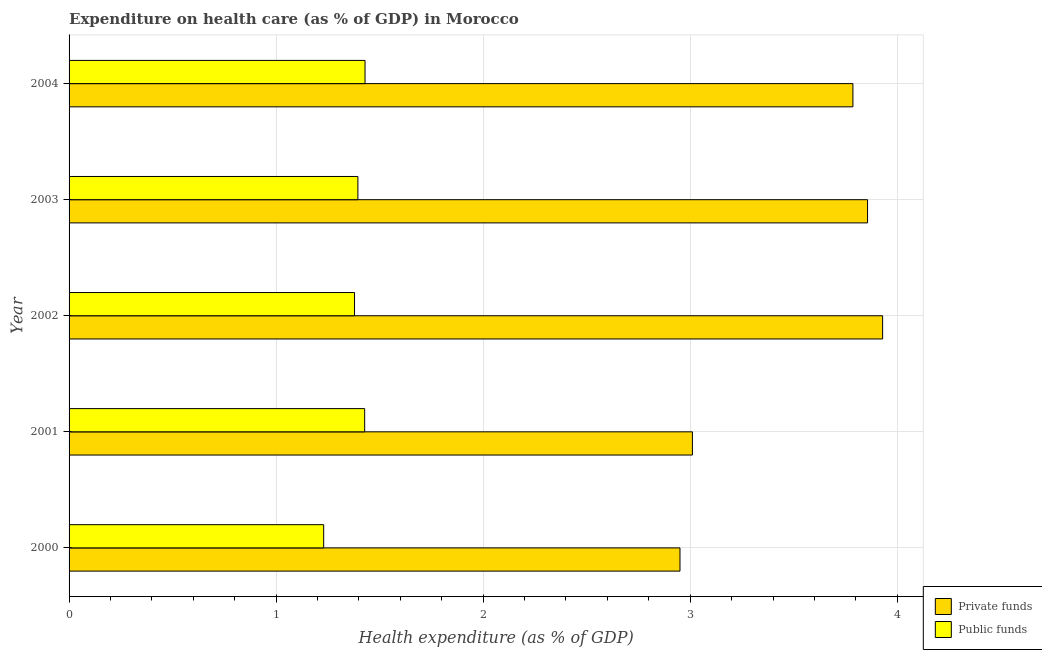Are the number of bars per tick equal to the number of legend labels?
Provide a succinct answer. Yes. Are the number of bars on each tick of the Y-axis equal?
Keep it short and to the point. Yes. How many bars are there on the 4th tick from the bottom?
Provide a short and direct response. 2. In how many cases, is the number of bars for a given year not equal to the number of legend labels?
Your response must be concise. 0. What is the amount of private funds spent in healthcare in 2004?
Offer a terse response. 3.79. Across all years, what is the maximum amount of public funds spent in healthcare?
Your response must be concise. 1.43. Across all years, what is the minimum amount of public funds spent in healthcare?
Offer a terse response. 1.23. What is the total amount of private funds spent in healthcare in the graph?
Provide a short and direct response. 17.53. What is the difference between the amount of private funds spent in healthcare in 2000 and that in 2003?
Your response must be concise. -0.91. What is the difference between the amount of public funds spent in healthcare in 2002 and the amount of private funds spent in healthcare in 2003?
Your response must be concise. -2.48. What is the average amount of public funds spent in healthcare per year?
Offer a very short reply. 1.37. In the year 2000, what is the difference between the amount of public funds spent in healthcare and amount of private funds spent in healthcare?
Your answer should be compact. -1.72. In how many years, is the amount of private funds spent in healthcare greater than 2.8 %?
Keep it short and to the point. 5. What is the ratio of the amount of private funds spent in healthcare in 2002 to that in 2004?
Provide a succinct answer. 1.04. What is the difference between the highest and the second highest amount of public funds spent in healthcare?
Your answer should be compact. 0. In how many years, is the amount of private funds spent in healthcare greater than the average amount of private funds spent in healthcare taken over all years?
Give a very brief answer. 3. What does the 2nd bar from the top in 2000 represents?
Ensure brevity in your answer.  Private funds. What does the 2nd bar from the bottom in 2004 represents?
Provide a succinct answer. Public funds. Are the values on the major ticks of X-axis written in scientific E-notation?
Your answer should be very brief. No. Does the graph contain any zero values?
Ensure brevity in your answer.  No. Does the graph contain grids?
Provide a short and direct response. Yes. Where does the legend appear in the graph?
Ensure brevity in your answer.  Bottom right. How many legend labels are there?
Ensure brevity in your answer.  2. What is the title of the graph?
Your response must be concise. Expenditure on health care (as % of GDP) in Morocco. Does "Non-pregnant women" appear as one of the legend labels in the graph?
Offer a terse response. No. What is the label or title of the X-axis?
Offer a very short reply. Health expenditure (as % of GDP). What is the label or title of the Y-axis?
Your answer should be compact. Year. What is the Health expenditure (as % of GDP) in Private funds in 2000?
Your answer should be very brief. 2.95. What is the Health expenditure (as % of GDP) in Public funds in 2000?
Provide a short and direct response. 1.23. What is the Health expenditure (as % of GDP) of Private funds in 2001?
Give a very brief answer. 3.01. What is the Health expenditure (as % of GDP) in Public funds in 2001?
Offer a terse response. 1.43. What is the Health expenditure (as % of GDP) of Private funds in 2002?
Your answer should be very brief. 3.93. What is the Health expenditure (as % of GDP) in Public funds in 2002?
Keep it short and to the point. 1.38. What is the Health expenditure (as % of GDP) in Private funds in 2003?
Your response must be concise. 3.86. What is the Health expenditure (as % of GDP) in Public funds in 2003?
Your response must be concise. 1.39. What is the Health expenditure (as % of GDP) of Private funds in 2004?
Your response must be concise. 3.79. What is the Health expenditure (as % of GDP) in Public funds in 2004?
Offer a terse response. 1.43. Across all years, what is the maximum Health expenditure (as % of GDP) of Private funds?
Your answer should be compact. 3.93. Across all years, what is the maximum Health expenditure (as % of GDP) in Public funds?
Keep it short and to the point. 1.43. Across all years, what is the minimum Health expenditure (as % of GDP) of Private funds?
Ensure brevity in your answer.  2.95. Across all years, what is the minimum Health expenditure (as % of GDP) in Public funds?
Give a very brief answer. 1.23. What is the total Health expenditure (as % of GDP) in Private funds in the graph?
Ensure brevity in your answer.  17.53. What is the total Health expenditure (as % of GDP) of Public funds in the graph?
Ensure brevity in your answer.  6.86. What is the difference between the Health expenditure (as % of GDP) in Private funds in 2000 and that in 2001?
Your answer should be very brief. -0.06. What is the difference between the Health expenditure (as % of GDP) of Public funds in 2000 and that in 2001?
Provide a succinct answer. -0.2. What is the difference between the Health expenditure (as % of GDP) in Private funds in 2000 and that in 2002?
Provide a short and direct response. -0.98. What is the difference between the Health expenditure (as % of GDP) of Public funds in 2000 and that in 2002?
Provide a short and direct response. -0.15. What is the difference between the Health expenditure (as % of GDP) of Private funds in 2000 and that in 2003?
Make the answer very short. -0.91. What is the difference between the Health expenditure (as % of GDP) of Public funds in 2000 and that in 2003?
Your answer should be compact. -0.17. What is the difference between the Health expenditure (as % of GDP) of Private funds in 2000 and that in 2004?
Ensure brevity in your answer.  -0.84. What is the difference between the Health expenditure (as % of GDP) in Public funds in 2000 and that in 2004?
Offer a terse response. -0.2. What is the difference between the Health expenditure (as % of GDP) of Private funds in 2001 and that in 2002?
Make the answer very short. -0.92. What is the difference between the Health expenditure (as % of GDP) of Public funds in 2001 and that in 2002?
Your response must be concise. 0.05. What is the difference between the Health expenditure (as % of GDP) of Private funds in 2001 and that in 2003?
Offer a very short reply. -0.85. What is the difference between the Health expenditure (as % of GDP) in Public funds in 2001 and that in 2003?
Keep it short and to the point. 0.03. What is the difference between the Health expenditure (as % of GDP) in Private funds in 2001 and that in 2004?
Provide a succinct answer. -0.78. What is the difference between the Health expenditure (as % of GDP) in Public funds in 2001 and that in 2004?
Ensure brevity in your answer.  -0. What is the difference between the Health expenditure (as % of GDP) in Private funds in 2002 and that in 2003?
Provide a short and direct response. 0.07. What is the difference between the Health expenditure (as % of GDP) in Public funds in 2002 and that in 2003?
Provide a short and direct response. -0.02. What is the difference between the Health expenditure (as % of GDP) in Private funds in 2002 and that in 2004?
Provide a short and direct response. 0.14. What is the difference between the Health expenditure (as % of GDP) in Public funds in 2002 and that in 2004?
Your answer should be compact. -0.05. What is the difference between the Health expenditure (as % of GDP) of Private funds in 2003 and that in 2004?
Offer a terse response. 0.07. What is the difference between the Health expenditure (as % of GDP) in Public funds in 2003 and that in 2004?
Ensure brevity in your answer.  -0.03. What is the difference between the Health expenditure (as % of GDP) in Private funds in 2000 and the Health expenditure (as % of GDP) in Public funds in 2001?
Make the answer very short. 1.52. What is the difference between the Health expenditure (as % of GDP) in Private funds in 2000 and the Health expenditure (as % of GDP) in Public funds in 2002?
Provide a short and direct response. 1.57. What is the difference between the Health expenditure (as % of GDP) in Private funds in 2000 and the Health expenditure (as % of GDP) in Public funds in 2003?
Offer a terse response. 1.56. What is the difference between the Health expenditure (as % of GDP) in Private funds in 2000 and the Health expenditure (as % of GDP) in Public funds in 2004?
Provide a short and direct response. 1.52. What is the difference between the Health expenditure (as % of GDP) of Private funds in 2001 and the Health expenditure (as % of GDP) of Public funds in 2002?
Provide a succinct answer. 1.63. What is the difference between the Health expenditure (as % of GDP) of Private funds in 2001 and the Health expenditure (as % of GDP) of Public funds in 2003?
Ensure brevity in your answer.  1.62. What is the difference between the Health expenditure (as % of GDP) in Private funds in 2001 and the Health expenditure (as % of GDP) in Public funds in 2004?
Provide a short and direct response. 1.58. What is the difference between the Health expenditure (as % of GDP) in Private funds in 2002 and the Health expenditure (as % of GDP) in Public funds in 2003?
Give a very brief answer. 2.53. What is the difference between the Health expenditure (as % of GDP) of Private funds in 2003 and the Health expenditure (as % of GDP) of Public funds in 2004?
Provide a short and direct response. 2.43. What is the average Health expenditure (as % of GDP) of Private funds per year?
Your answer should be very brief. 3.51. What is the average Health expenditure (as % of GDP) of Public funds per year?
Offer a terse response. 1.37. In the year 2000, what is the difference between the Health expenditure (as % of GDP) of Private funds and Health expenditure (as % of GDP) of Public funds?
Your answer should be compact. 1.72. In the year 2001, what is the difference between the Health expenditure (as % of GDP) in Private funds and Health expenditure (as % of GDP) in Public funds?
Ensure brevity in your answer.  1.58. In the year 2002, what is the difference between the Health expenditure (as % of GDP) in Private funds and Health expenditure (as % of GDP) in Public funds?
Your answer should be very brief. 2.55. In the year 2003, what is the difference between the Health expenditure (as % of GDP) in Private funds and Health expenditure (as % of GDP) in Public funds?
Keep it short and to the point. 2.46. In the year 2004, what is the difference between the Health expenditure (as % of GDP) in Private funds and Health expenditure (as % of GDP) in Public funds?
Your answer should be very brief. 2.36. What is the ratio of the Health expenditure (as % of GDP) in Private funds in 2000 to that in 2001?
Keep it short and to the point. 0.98. What is the ratio of the Health expenditure (as % of GDP) of Public funds in 2000 to that in 2001?
Make the answer very short. 0.86. What is the ratio of the Health expenditure (as % of GDP) in Private funds in 2000 to that in 2002?
Give a very brief answer. 0.75. What is the ratio of the Health expenditure (as % of GDP) of Public funds in 2000 to that in 2002?
Keep it short and to the point. 0.89. What is the ratio of the Health expenditure (as % of GDP) of Private funds in 2000 to that in 2003?
Ensure brevity in your answer.  0.77. What is the ratio of the Health expenditure (as % of GDP) in Public funds in 2000 to that in 2003?
Give a very brief answer. 0.88. What is the ratio of the Health expenditure (as % of GDP) in Private funds in 2000 to that in 2004?
Provide a succinct answer. 0.78. What is the ratio of the Health expenditure (as % of GDP) of Public funds in 2000 to that in 2004?
Make the answer very short. 0.86. What is the ratio of the Health expenditure (as % of GDP) of Private funds in 2001 to that in 2002?
Keep it short and to the point. 0.77. What is the ratio of the Health expenditure (as % of GDP) in Public funds in 2001 to that in 2002?
Provide a short and direct response. 1.04. What is the ratio of the Health expenditure (as % of GDP) in Private funds in 2001 to that in 2003?
Your response must be concise. 0.78. What is the ratio of the Health expenditure (as % of GDP) of Public funds in 2001 to that in 2003?
Your response must be concise. 1.02. What is the ratio of the Health expenditure (as % of GDP) of Private funds in 2001 to that in 2004?
Keep it short and to the point. 0.8. What is the ratio of the Health expenditure (as % of GDP) in Public funds in 2001 to that in 2004?
Your response must be concise. 1. What is the ratio of the Health expenditure (as % of GDP) of Private funds in 2002 to that in 2003?
Keep it short and to the point. 1.02. What is the ratio of the Health expenditure (as % of GDP) in Public funds in 2002 to that in 2003?
Your response must be concise. 0.99. What is the ratio of the Health expenditure (as % of GDP) of Private funds in 2002 to that in 2004?
Provide a succinct answer. 1.04. What is the ratio of the Health expenditure (as % of GDP) of Public funds in 2002 to that in 2004?
Your response must be concise. 0.96. What is the ratio of the Health expenditure (as % of GDP) in Private funds in 2003 to that in 2004?
Your response must be concise. 1.02. What is the ratio of the Health expenditure (as % of GDP) in Public funds in 2003 to that in 2004?
Your response must be concise. 0.98. What is the difference between the highest and the second highest Health expenditure (as % of GDP) of Private funds?
Ensure brevity in your answer.  0.07. What is the difference between the highest and the second highest Health expenditure (as % of GDP) in Public funds?
Your answer should be very brief. 0. What is the difference between the highest and the lowest Health expenditure (as % of GDP) in Private funds?
Ensure brevity in your answer.  0.98. What is the difference between the highest and the lowest Health expenditure (as % of GDP) of Public funds?
Your answer should be very brief. 0.2. 